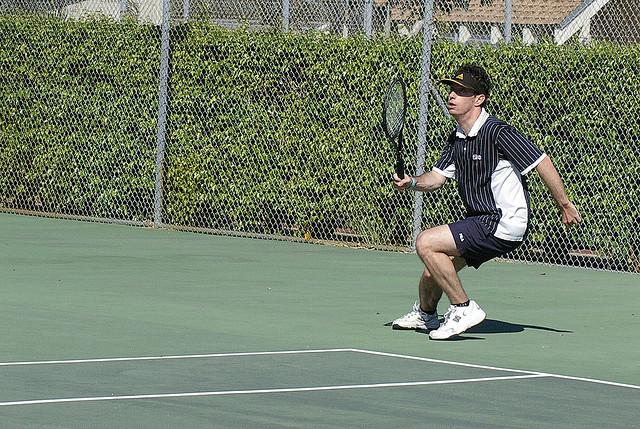How many tennis racquets are there?
Quick response, please. 1. Is his color shorts white?
Write a very short answer. No. Will the tennis player be able fall over?
Give a very brief answer. Yes. Is the man moving?
Be succinct. Yes. 